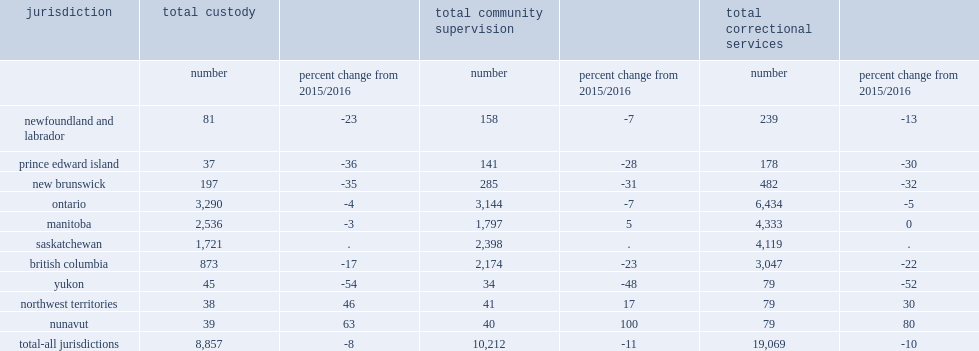In 2016/2017, what was the total number of youth admissions to correctional services among the 10 reporting jurisdictions? 19069.0. In 2016/2017, the total number of youth admissions to correctional services among the 10 reporting jurisdictions, how many percent of a decrease when compared to 2015/2016? 10. How many percent did admissions to community supervision decreas by? 11. How many percent did admissions to custody decreas by? 8. How many percent of nunavut which had the largest increase in total admissions? 80.0. How many percent of yukon which had the largest decrease in admissions? 52. 